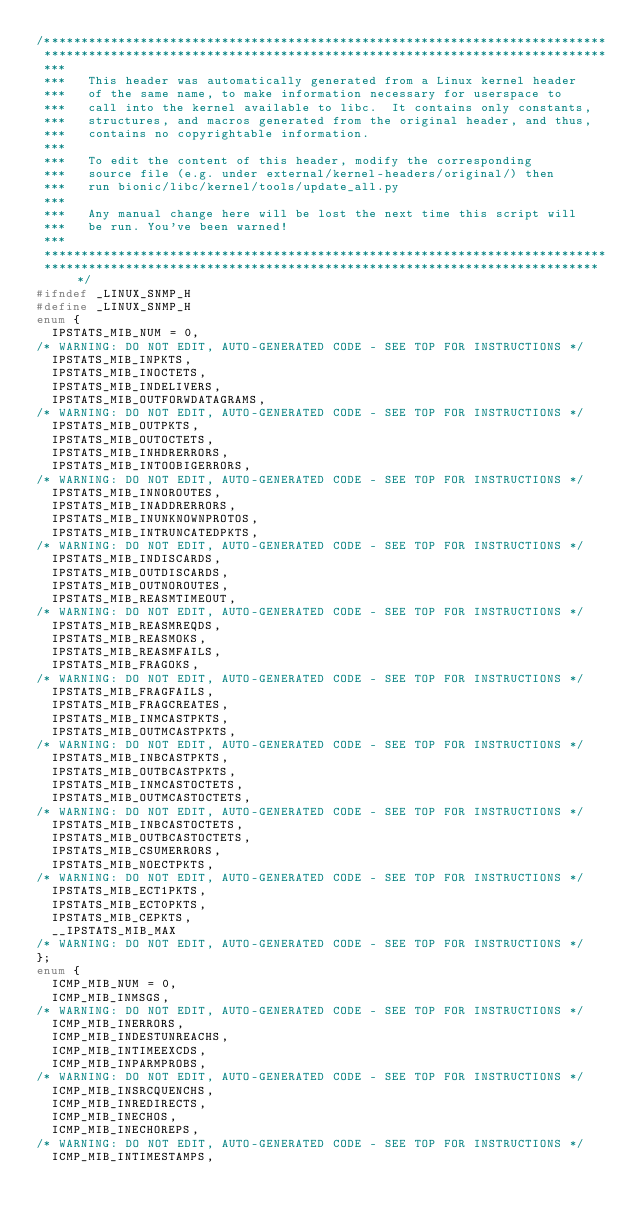Convert code to text. <code><loc_0><loc_0><loc_500><loc_500><_C_>/****************************************************************************
 ****************************************************************************
 ***
 ***   This header was automatically generated from a Linux kernel header
 ***   of the same name, to make information necessary for userspace to
 ***   call into the kernel available to libc.  It contains only constants,
 ***   structures, and macros generated from the original header, and thus,
 ***   contains no copyrightable information.
 ***
 ***   To edit the content of this header, modify the corresponding
 ***   source file (e.g. under external/kernel-headers/original/) then
 ***   run bionic/libc/kernel/tools/update_all.py
 ***
 ***   Any manual change here will be lost the next time this script will
 ***   be run. You've been warned!
 ***
 ****************************************************************************
 ****************************************************************************/
#ifndef _LINUX_SNMP_H
#define _LINUX_SNMP_H
enum {
  IPSTATS_MIB_NUM = 0,
/* WARNING: DO NOT EDIT, AUTO-GENERATED CODE - SEE TOP FOR INSTRUCTIONS */
  IPSTATS_MIB_INPKTS,
  IPSTATS_MIB_INOCTETS,
  IPSTATS_MIB_INDELIVERS,
  IPSTATS_MIB_OUTFORWDATAGRAMS,
/* WARNING: DO NOT EDIT, AUTO-GENERATED CODE - SEE TOP FOR INSTRUCTIONS */
  IPSTATS_MIB_OUTPKTS,
  IPSTATS_MIB_OUTOCTETS,
  IPSTATS_MIB_INHDRERRORS,
  IPSTATS_MIB_INTOOBIGERRORS,
/* WARNING: DO NOT EDIT, AUTO-GENERATED CODE - SEE TOP FOR INSTRUCTIONS */
  IPSTATS_MIB_INNOROUTES,
  IPSTATS_MIB_INADDRERRORS,
  IPSTATS_MIB_INUNKNOWNPROTOS,
  IPSTATS_MIB_INTRUNCATEDPKTS,
/* WARNING: DO NOT EDIT, AUTO-GENERATED CODE - SEE TOP FOR INSTRUCTIONS */
  IPSTATS_MIB_INDISCARDS,
  IPSTATS_MIB_OUTDISCARDS,
  IPSTATS_MIB_OUTNOROUTES,
  IPSTATS_MIB_REASMTIMEOUT,
/* WARNING: DO NOT EDIT, AUTO-GENERATED CODE - SEE TOP FOR INSTRUCTIONS */
  IPSTATS_MIB_REASMREQDS,
  IPSTATS_MIB_REASMOKS,
  IPSTATS_MIB_REASMFAILS,
  IPSTATS_MIB_FRAGOKS,
/* WARNING: DO NOT EDIT, AUTO-GENERATED CODE - SEE TOP FOR INSTRUCTIONS */
  IPSTATS_MIB_FRAGFAILS,
  IPSTATS_MIB_FRAGCREATES,
  IPSTATS_MIB_INMCASTPKTS,
  IPSTATS_MIB_OUTMCASTPKTS,
/* WARNING: DO NOT EDIT, AUTO-GENERATED CODE - SEE TOP FOR INSTRUCTIONS */
  IPSTATS_MIB_INBCASTPKTS,
  IPSTATS_MIB_OUTBCASTPKTS,
  IPSTATS_MIB_INMCASTOCTETS,
  IPSTATS_MIB_OUTMCASTOCTETS,
/* WARNING: DO NOT EDIT, AUTO-GENERATED CODE - SEE TOP FOR INSTRUCTIONS */
  IPSTATS_MIB_INBCASTOCTETS,
  IPSTATS_MIB_OUTBCASTOCTETS,
  IPSTATS_MIB_CSUMERRORS,
  IPSTATS_MIB_NOECTPKTS,
/* WARNING: DO NOT EDIT, AUTO-GENERATED CODE - SEE TOP FOR INSTRUCTIONS */
  IPSTATS_MIB_ECT1PKTS,
  IPSTATS_MIB_ECT0PKTS,
  IPSTATS_MIB_CEPKTS,
  __IPSTATS_MIB_MAX
/* WARNING: DO NOT EDIT, AUTO-GENERATED CODE - SEE TOP FOR INSTRUCTIONS */
};
enum {
  ICMP_MIB_NUM = 0,
  ICMP_MIB_INMSGS,
/* WARNING: DO NOT EDIT, AUTO-GENERATED CODE - SEE TOP FOR INSTRUCTIONS */
  ICMP_MIB_INERRORS,
  ICMP_MIB_INDESTUNREACHS,
  ICMP_MIB_INTIMEEXCDS,
  ICMP_MIB_INPARMPROBS,
/* WARNING: DO NOT EDIT, AUTO-GENERATED CODE - SEE TOP FOR INSTRUCTIONS */
  ICMP_MIB_INSRCQUENCHS,
  ICMP_MIB_INREDIRECTS,
  ICMP_MIB_INECHOS,
  ICMP_MIB_INECHOREPS,
/* WARNING: DO NOT EDIT, AUTO-GENERATED CODE - SEE TOP FOR INSTRUCTIONS */
  ICMP_MIB_INTIMESTAMPS,</code> 